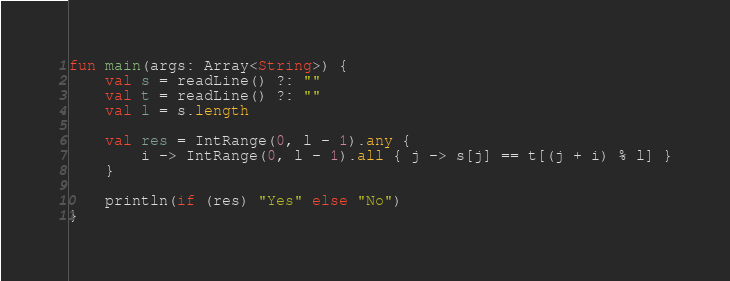<code> <loc_0><loc_0><loc_500><loc_500><_Kotlin_>fun main(args: Array<String>) {
    val s = readLine() ?: ""
    val t = readLine() ?: ""
    val l = s.length

    val res = IntRange(0, l - 1).any {
        i -> IntRange(0, l - 1).all { j -> s[j] == t[(j + i) % l] }
    }

    println(if (res) "Yes" else "No")
}</code> 